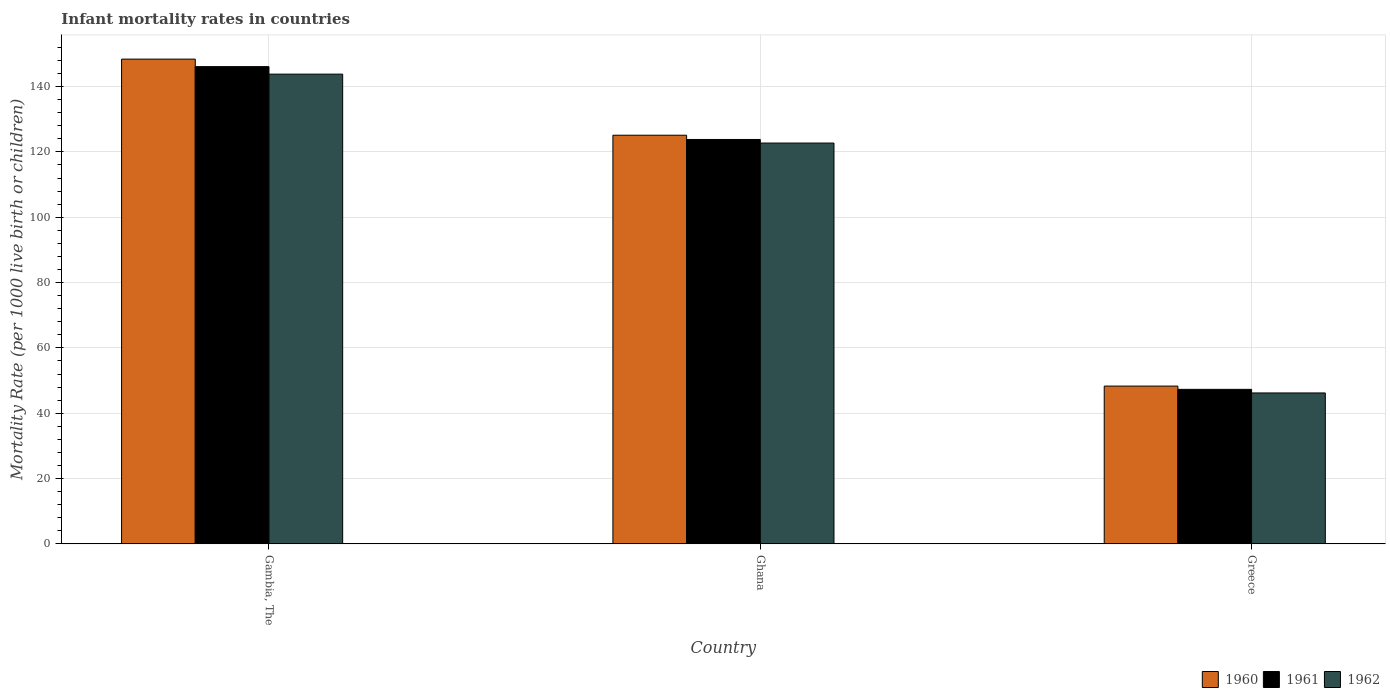Are the number of bars per tick equal to the number of legend labels?
Ensure brevity in your answer.  Yes. Are the number of bars on each tick of the X-axis equal?
Offer a terse response. Yes. What is the label of the 1st group of bars from the left?
Keep it short and to the point. Gambia, The. What is the infant mortality rate in 1962 in Ghana?
Provide a succinct answer. 122.7. Across all countries, what is the maximum infant mortality rate in 1961?
Ensure brevity in your answer.  146.1. Across all countries, what is the minimum infant mortality rate in 1961?
Provide a succinct answer. 47.3. In which country was the infant mortality rate in 1962 maximum?
Offer a terse response. Gambia, The. What is the total infant mortality rate in 1962 in the graph?
Offer a very short reply. 312.7. What is the difference between the infant mortality rate in 1962 in Gambia, The and that in Greece?
Offer a terse response. 97.6. What is the difference between the infant mortality rate in 1962 in Gambia, The and the infant mortality rate in 1961 in Ghana?
Provide a short and direct response. 20. What is the average infant mortality rate in 1960 per country?
Your answer should be very brief. 107.27. What is the difference between the infant mortality rate of/in 1962 and infant mortality rate of/in 1961 in Greece?
Provide a succinct answer. -1.1. In how many countries, is the infant mortality rate in 1960 greater than 104?
Give a very brief answer. 2. What is the ratio of the infant mortality rate in 1960 in Ghana to that in Greece?
Provide a succinct answer. 2.59. What is the difference between the highest and the second highest infant mortality rate in 1961?
Keep it short and to the point. 22.3. What is the difference between the highest and the lowest infant mortality rate in 1962?
Your answer should be compact. 97.6. Is the sum of the infant mortality rate in 1961 in Ghana and Greece greater than the maximum infant mortality rate in 1960 across all countries?
Provide a short and direct response. Yes. What does the 2nd bar from the left in Gambia, The represents?
Give a very brief answer. 1961. What does the 3rd bar from the right in Gambia, The represents?
Provide a short and direct response. 1960. How many bars are there?
Offer a terse response. 9. Are all the bars in the graph horizontal?
Your answer should be very brief. No. What is the title of the graph?
Keep it short and to the point. Infant mortality rates in countries. What is the label or title of the Y-axis?
Keep it short and to the point. Mortality Rate (per 1000 live birth or children). What is the Mortality Rate (per 1000 live birth or children) of 1960 in Gambia, The?
Make the answer very short. 148.4. What is the Mortality Rate (per 1000 live birth or children) of 1961 in Gambia, The?
Provide a short and direct response. 146.1. What is the Mortality Rate (per 1000 live birth or children) in 1962 in Gambia, The?
Keep it short and to the point. 143.8. What is the Mortality Rate (per 1000 live birth or children) in 1960 in Ghana?
Keep it short and to the point. 125.1. What is the Mortality Rate (per 1000 live birth or children) in 1961 in Ghana?
Your response must be concise. 123.8. What is the Mortality Rate (per 1000 live birth or children) in 1962 in Ghana?
Your answer should be very brief. 122.7. What is the Mortality Rate (per 1000 live birth or children) in 1960 in Greece?
Your answer should be very brief. 48.3. What is the Mortality Rate (per 1000 live birth or children) in 1961 in Greece?
Your answer should be compact. 47.3. What is the Mortality Rate (per 1000 live birth or children) of 1962 in Greece?
Your answer should be very brief. 46.2. Across all countries, what is the maximum Mortality Rate (per 1000 live birth or children) in 1960?
Ensure brevity in your answer.  148.4. Across all countries, what is the maximum Mortality Rate (per 1000 live birth or children) in 1961?
Offer a terse response. 146.1. Across all countries, what is the maximum Mortality Rate (per 1000 live birth or children) of 1962?
Ensure brevity in your answer.  143.8. Across all countries, what is the minimum Mortality Rate (per 1000 live birth or children) of 1960?
Provide a short and direct response. 48.3. Across all countries, what is the minimum Mortality Rate (per 1000 live birth or children) in 1961?
Your answer should be very brief. 47.3. Across all countries, what is the minimum Mortality Rate (per 1000 live birth or children) of 1962?
Your response must be concise. 46.2. What is the total Mortality Rate (per 1000 live birth or children) in 1960 in the graph?
Provide a short and direct response. 321.8. What is the total Mortality Rate (per 1000 live birth or children) of 1961 in the graph?
Provide a short and direct response. 317.2. What is the total Mortality Rate (per 1000 live birth or children) of 1962 in the graph?
Offer a very short reply. 312.7. What is the difference between the Mortality Rate (per 1000 live birth or children) of 1960 in Gambia, The and that in Ghana?
Your answer should be very brief. 23.3. What is the difference between the Mortality Rate (per 1000 live birth or children) of 1961 in Gambia, The and that in Ghana?
Provide a short and direct response. 22.3. What is the difference between the Mortality Rate (per 1000 live birth or children) in 1962 in Gambia, The and that in Ghana?
Keep it short and to the point. 21.1. What is the difference between the Mortality Rate (per 1000 live birth or children) of 1960 in Gambia, The and that in Greece?
Offer a very short reply. 100.1. What is the difference between the Mortality Rate (per 1000 live birth or children) in 1961 in Gambia, The and that in Greece?
Offer a very short reply. 98.8. What is the difference between the Mortality Rate (per 1000 live birth or children) of 1962 in Gambia, The and that in Greece?
Provide a succinct answer. 97.6. What is the difference between the Mortality Rate (per 1000 live birth or children) in 1960 in Ghana and that in Greece?
Offer a very short reply. 76.8. What is the difference between the Mortality Rate (per 1000 live birth or children) in 1961 in Ghana and that in Greece?
Keep it short and to the point. 76.5. What is the difference between the Mortality Rate (per 1000 live birth or children) of 1962 in Ghana and that in Greece?
Ensure brevity in your answer.  76.5. What is the difference between the Mortality Rate (per 1000 live birth or children) of 1960 in Gambia, The and the Mortality Rate (per 1000 live birth or children) of 1961 in Ghana?
Provide a succinct answer. 24.6. What is the difference between the Mortality Rate (per 1000 live birth or children) of 1960 in Gambia, The and the Mortality Rate (per 1000 live birth or children) of 1962 in Ghana?
Offer a very short reply. 25.7. What is the difference between the Mortality Rate (per 1000 live birth or children) in 1961 in Gambia, The and the Mortality Rate (per 1000 live birth or children) in 1962 in Ghana?
Your answer should be very brief. 23.4. What is the difference between the Mortality Rate (per 1000 live birth or children) of 1960 in Gambia, The and the Mortality Rate (per 1000 live birth or children) of 1961 in Greece?
Provide a short and direct response. 101.1. What is the difference between the Mortality Rate (per 1000 live birth or children) of 1960 in Gambia, The and the Mortality Rate (per 1000 live birth or children) of 1962 in Greece?
Provide a succinct answer. 102.2. What is the difference between the Mortality Rate (per 1000 live birth or children) of 1961 in Gambia, The and the Mortality Rate (per 1000 live birth or children) of 1962 in Greece?
Provide a succinct answer. 99.9. What is the difference between the Mortality Rate (per 1000 live birth or children) of 1960 in Ghana and the Mortality Rate (per 1000 live birth or children) of 1961 in Greece?
Give a very brief answer. 77.8. What is the difference between the Mortality Rate (per 1000 live birth or children) in 1960 in Ghana and the Mortality Rate (per 1000 live birth or children) in 1962 in Greece?
Make the answer very short. 78.9. What is the difference between the Mortality Rate (per 1000 live birth or children) in 1961 in Ghana and the Mortality Rate (per 1000 live birth or children) in 1962 in Greece?
Your response must be concise. 77.6. What is the average Mortality Rate (per 1000 live birth or children) of 1960 per country?
Your response must be concise. 107.27. What is the average Mortality Rate (per 1000 live birth or children) of 1961 per country?
Provide a succinct answer. 105.73. What is the average Mortality Rate (per 1000 live birth or children) of 1962 per country?
Provide a short and direct response. 104.23. What is the difference between the Mortality Rate (per 1000 live birth or children) of 1960 and Mortality Rate (per 1000 live birth or children) of 1962 in Gambia, The?
Offer a very short reply. 4.6. What is the difference between the Mortality Rate (per 1000 live birth or children) of 1960 and Mortality Rate (per 1000 live birth or children) of 1962 in Ghana?
Your answer should be very brief. 2.4. What is the difference between the Mortality Rate (per 1000 live birth or children) in 1960 and Mortality Rate (per 1000 live birth or children) in 1961 in Greece?
Ensure brevity in your answer.  1. What is the difference between the Mortality Rate (per 1000 live birth or children) in 1960 and Mortality Rate (per 1000 live birth or children) in 1962 in Greece?
Provide a succinct answer. 2.1. What is the ratio of the Mortality Rate (per 1000 live birth or children) of 1960 in Gambia, The to that in Ghana?
Your answer should be very brief. 1.19. What is the ratio of the Mortality Rate (per 1000 live birth or children) of 1961 in Gambia, The to that in Ghana?
Give a very brief answer. 1.18. What is the ratio of the Mortality Rate (per 1000 live birth or children) in 1962 in Gambia, The to that in Ghana?
Give a very brief answer. 1.17. What is the ratio of the Mortality Rate (per 1000 live birth or children) in 1960 in Gambia, The to that in Greece?
Your answer should be very brief. 3.07. What is the ratio of the Mortality Rate (per 1000 live birth or children) of 1961 in Gambia, The to that in Greece?
Keep it short and to the point. 3.09. What is the ratio of the Mortality Rate (per 1000 live birth or children) in 1962 in Gambia, The to that in Greece?
Your answer should be compact. 3.11. What is the ratio of the Mortality Rate (per 1000 live birth or children) of 1960 in Ghana to that in Greece?
Make the answer very short. 2.59. What is the ratio of the Mortality Rate (per 1000 live birth or children) of 1961 in Ghana to that in Greece?
Offer a very short reply. 2.62. What is the ratio of the Mortality Rate (per 1000 live birth or children) in 1962 in Ghana to that in Greece?
Ensure brevity in your answer.  2.66. What is the difference between the highest and the second highest Mortality Rate (per 1000 live birth or children) in 1960?
Offer a very short reply. 23.3. What is the difference between the highest and the second highest Mortality Rate (per 1000 live birth or children) of 1961?
Offer a terse response. 22.3. What is the difference between the highest and the second highest Mortality Rate (per 1000 live birth or children) in 1962?
Your answer should be compact. 21.1. What is the difference between the highest and the lowest Mortality Rate (per 1000 live birth or children) of 1960?
Your answer should be compact. 100.1. What is the difference between the highest and the lowest Mortality Rate (per 1000 live birth or children) in 1961?
Ensure brevity in your answer.  98.8. What is the difference between the highest and the lowest Mortality Rate (per 1000 live birth or children) of 1962?
Offer a very short reply. 97.6. 